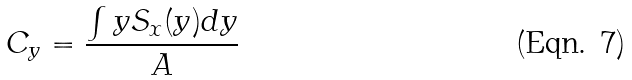Convert formula to latex. <formula><loc_0><loc_0><loc_500><loc_500>C _ { y } = \frac { \int y S _ { x } ( y ) d y } { A }</formula> 